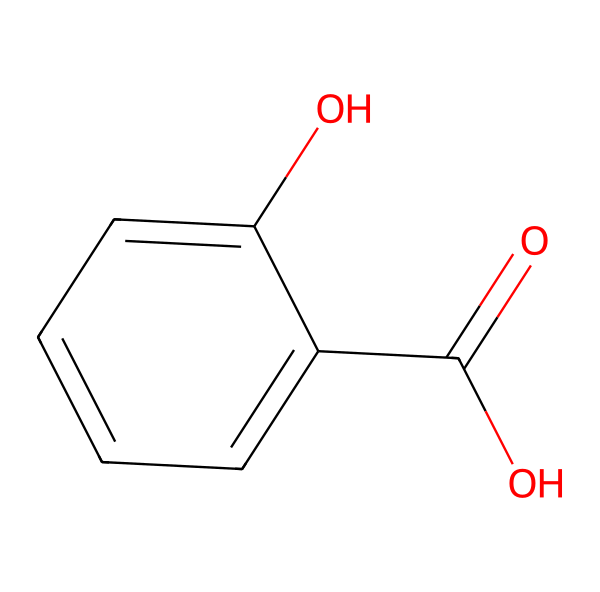What is the molecular formula of salicylic acid? To determine the molecular formula, count each type of atom in the structure. The structure has 7 carbon (C) atoms, 6 hydrogen (H) atoms, and 3 oxygen (O) atoms. Therefore, the molecular formula is C7H6O3.
Answer: C7H6O3 How many hydroxyl (–OH) groups are present in salicylic acid? In the structure, identify the –OH groups. There is one –OH group directly attached to the aromatic ring and another part of the carboxylic acid group (-COOH). This totals to 2 hydroxyl groups in salicylic acid.
Answer: 2 What type of functional group is represented by the –COOH in salicylic acid? The –COOH group is a carboxylic acid functional group. It can be identified by its structure, which consists of a carbonyl (C=O) and a hydroxyl (–OH) group attached to the same carbon atom.
Answer: carboxylic acid What type of reaction can salicylic acid undergo due to the presence of the hydroxyl group? The hydroxyl group can participate in reactions characteristic of alcohols, such as dehydration or esterification. The presence of the –OH group makes salicylic acid capable of forming ester bonds in certain reactions.
Answer: esterification What is the position of the hydroxyl group relative to the carboxyl group in salicylic acid? In salicylic acid, the hydroxyl group is ortho to the carboxyl group. This is identified by analyzing the positions of the substituents on the benzene ring; both groups are adjacent to each other on the ring.
Answer: ortho Is salicylic acid considered a phenolic compound? Yes, salicylic acid is a phenolic compound because it contains a hydroxyl group attached to an aromatic ring, classifying it under the phenols due to its structural characteristics.
Answer: Yes 